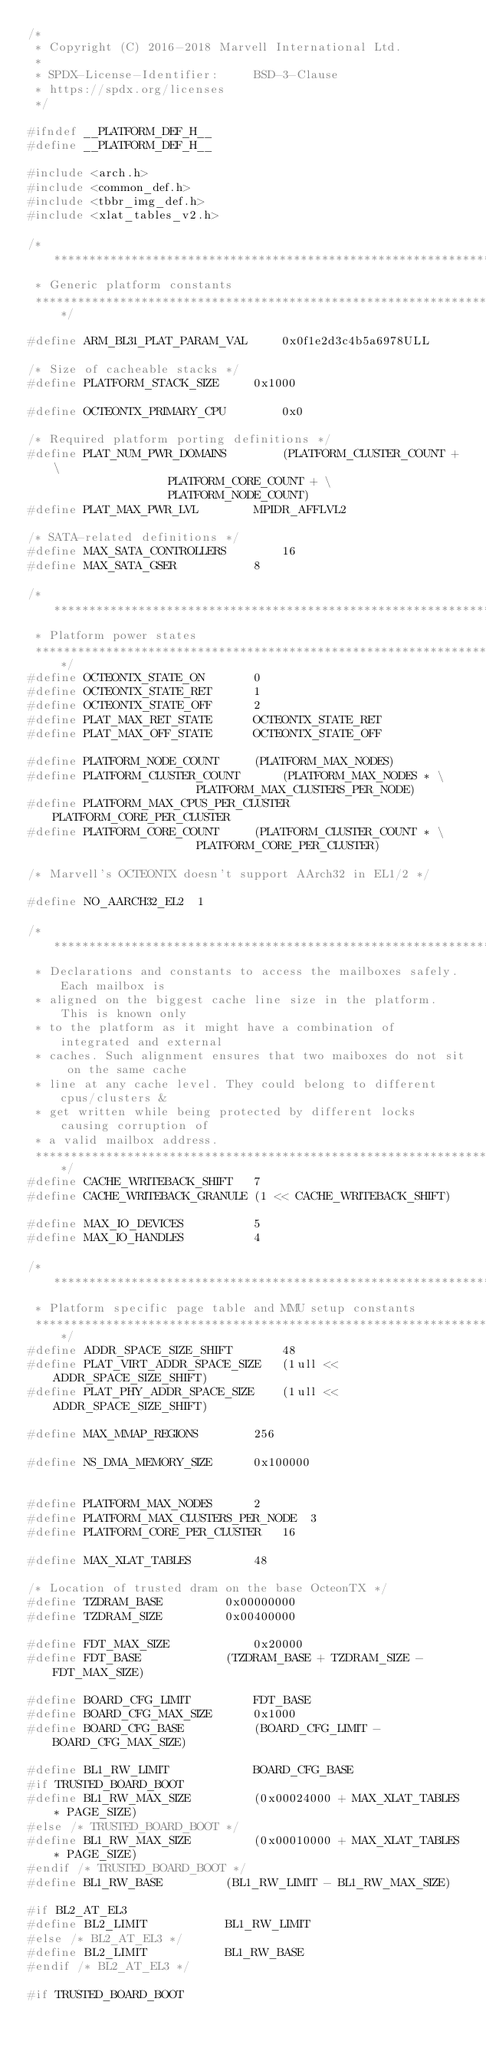Convert code to text. <code><loc_0><loc_0><loc_500><loc_500><_C_>/*
 * Copyright (C) 2016-2018 Marvell International Ltd.
 *
 * SPDX-License-Identifier:     BSD-3-Clause
 * https://spdx.org/licenses
 */

#ifndef __PLATFORM_DEF_H__
#define __PLATFORM_DEF_H__

#include <arch.h>
#include <common_def.h>
#include <tbbr_img_def.h>
#include <xlat_tables_v2.h>

/*******************************************************************************
 * Generic platform constants
 ******************************************************************************/

#define ARM_BL31_PLAT_PARAM_VAL		0x0f1e2d3c4b5a6978ULL

/* Size of cacheable stacks */
#define PLATFORM_STACK_SIZE		0x1000

#define OCTEONTX_PRIMARY_CPU		0x0

/* Required platform porting definitions */
#define PLAT_NUM_PWR_DOMAINS		(PLATFORM_CLUSTER_COUNT + \
					PLATFORM_CORE_COUNT + \
					PLATFORM_NODE_COUNT)
#define PLAT_MAX_PWR_LVL		MPIDR_AFFLVL2

/* SATA-related definitions */
#define MAX_SATA_CONTROLLERS		16
#define MAX_SATA_GSER			8

/*******************************************************************************
 * Platform power states
 ******************************************************************************/
#define OCTEONTX_STATE_ON		0
#define OCTEONTX_STATE_RET		1
#define OCTEONTX_STATE_OFF		2
#define PLAT_MAX_RET_STATE		OCTEONTX_STATE_RET
#define PLAT_MAX_OFF_STATE		OCTEONTX_STATE_OFF

#define PLATFORM_NODE_COUNT		(PLATFORM_MAX_NODES)
#define PLATFORM_CLUSTER_COUNT		(PLATFORM_MAX_NODES * \
						PLATFORM_MAX_CLUSTERS_PER_NODE)
#define PLATFORM_MAX_CPUS_PER_CLUSTER	PLATFORM_CORE_PER_CLUSTER
#define PLATFORM_CORE_COUNT		(PLATFORM_CLUSTER_COUNT * \
						PLATFORM_CORE_PER_CLUSTER)

/* Marvell's OCTEONTX doesn't support AArch32 in EL1/2 */

#define NO_AARCH32_EL2	1

/*******************************************************************************
 * Declarations and constants to access the mailboxes safely. Each mailbox is
 * aligned on the biggest cache line size in the platform. This is known only
 * to the platform as it might have a combination of integrated and external
 * caches. Such alignment ensures that two maiboxes do not sit on the same cache
 * line at any cache level. They could belong to different cpus/clusters &
 * get written while being protected by different locks causing corruption of
 * a valid mailbox address.
 ******************************************************************************/
#define CACHE_WRITEBACK_SHIFT   7
#define CACHE_WRITEBACK_GRANULE (1 << CACHE_WRITEBACK_SHIFT)

#define MAX_IO_DEVICES			5
#define MAX_IO_HANDLES			4

/*******************************************************************************
 * Platform specific page table and MMU setup constants
 ******************************************************************************/
#define ADDR_SPACE_SIZE_SHIFT		48
#define PLAT_VIRT_ADDR_SPACE_SIZE	(1ull << ADDR_SPACE_SIZE_SHIFT)
#define PLAT_PHY_ADDR_SPACE_SIZE	(1ull << ADDR_SPACE_SIZE_SHIFT)

#define MAX_MMAP_REGIONS		256

#define NS_DMA_MEMORY_SIZE		0x100000


#define PLATFORM_MAX_NODES		2
#define PLATFORM_MAX_CLUSTERS_PER_NODE	3
#define PLATFORM_CORE_PER_CLUSTER	16

#define MAX_XLAT_TABLES			48

/* Location of trusted dram on the base OcteonTX */
#define TZDRAM_BASE			0x00000000
#define TZDRAM_SIZE			0x00400000

#define FDT_MAX_SIZE			0x20000
#define FDT_BASE			(TZDRAM_BASE + TZDRAM_SIZE - FDT_MAX_SIZE)

#define BOARD_CFG_LIMIT			FDT_BASE
#define BOARD_CFG_MAX_SIZE		0x1000
#define BOARD_CFG_BASE			(BOARD_CFG_LIMIT - BOARD_CFG_MAX_SIZE)

#define BL1_RW_LIMIT			BOARD_CFG_BASE
#if TRUSTED_BOARD_BOOT
#define BL1_RW_MAX_SIZE			(0x00024000 + MAX_XLAT_TABLES * PAGE_SIZE)
#else /* TRUSTED_BOARD_BOOT */
#define BL1_RW_MAX_SIZE			(0x00010000 + MAX_XLAT_TABLES * PAGE_SIZE)
#endif /* TRUSTED_BOARD_BOOT */
#define BL1_RW_BASE			(BL1_RW_LIMIT - BL1_RW_MAX_SIZE)

#if BL2_AT_EL3
#define BL2_LIMIT			BL1_RW_LIMIT
#else /* BL2_AT_EL3 */
#define BL2_LIMIT			BL1_RW_BASE
#endif /* BL2_AT_EL3 */

#if TRUSTED_BOARD_BOOT</code> 